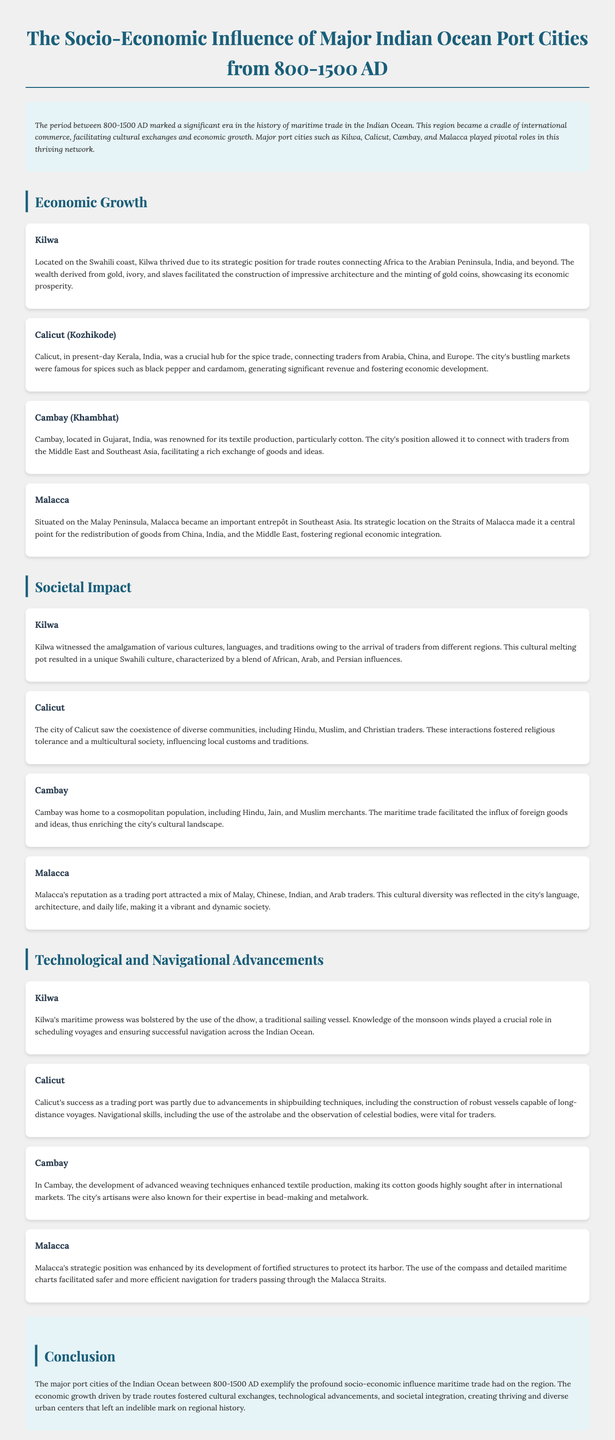what is the time period discussed in the document? The document focuses on the socio-economic influence from 800-1500 AD.
Answer: 800-1500 AD which port city was a crucial hub for the spice trade? The document highlights Calicut as a critical port for the spice trade.
Answer: Calicut what type of traditional sailing vessel was used in Kilwa? The document mentions the dhow as the traditional vessel used in Kilwa.
Answer: dhow what product was Cambay renowned for producing? The document states that Cambay was famous for its textile production, specifically cotton.
Answer: cotton which port city was located on the Malay Peninsula? The document specifies that Malacca is situated on the Malay Peninsula.
Answer: Malacca how did Calicut facilitate religious tolerance? The coexistence of diverse communities, including Hindu, Muslim, and Christian traders, fostered religious tolerance.
Answer: diverse communities what geographic feature enhanced Malacca's strategic position? The document describes Malacca's location on the Straits of Malacca, enhancing its strategic importance.
Answer: Straits of Malacca what was a significant factor for Kilwa's maritime success? Knowledge of the monsoon winds was crucial for Kilwa's maritime success.
Answer: monsoon winds which two cultures contributed to the unique Swahili culture in Kilwa? The document indicates a blend of African, Arab, and Persian influences in Kilwa.
Answer: African, Arab, and Persian influences 